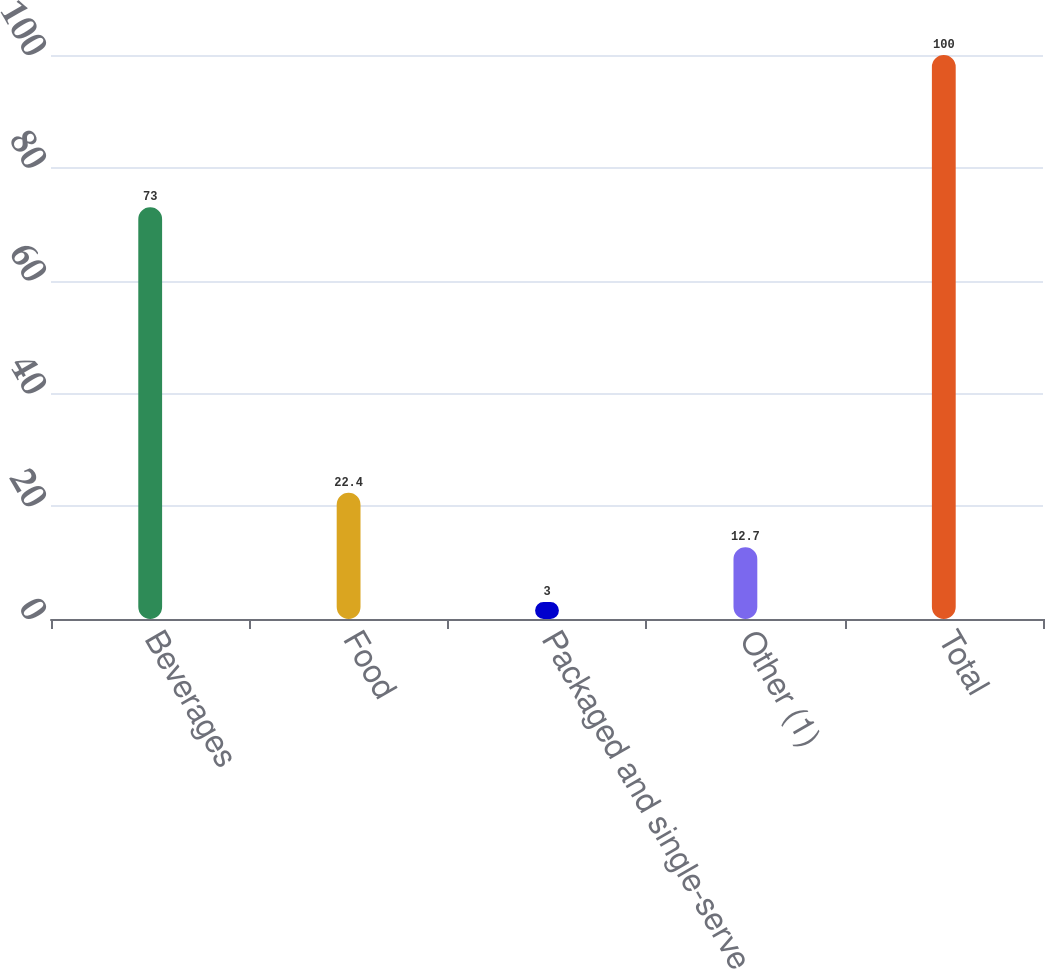Convert chart to OTSL. <chart><loc_0><loc_0><loc_500><loc_500><bar_chart><fcel>Beverages<fcel>Food<fcel>Packaged and single-serve<fcel>Other (1)<fcel>Total<nl><fcel>73<fcel>22.4<fcel>3<fcel>12.7<fcel>100<nl></chart> 